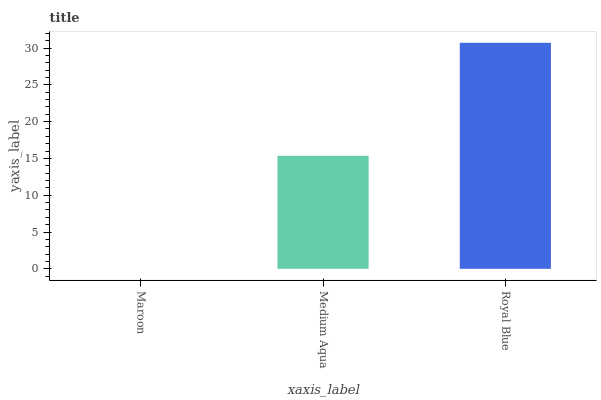Is Maroon the minimum?
Answer yes or no. Yes. Is Royal Blue the maximum?
Answer yes or no. Yes. Is Medium Aqua the minimum?
Answer yes or no. No. Is Medium Aqua the maximum?
Answer yes or no. No. Is Medium Aqua greater than Maroon?
Answer yes or no. Yes. Is Maroon less than Medium Aqua?
Answer yes or no. Yes. Is Maroon greater than Medium Aqua?
Answer yes or no. No. Is Medium Aqua less than Maroon?
Answer yes or no. No. Is Medium Aqua the high median?
Answer yes or no. Yes. Is Medium Aqua the low median?
Answer yes or no. Yes. Is Maroon the high median?
Answer yes or no. No. Is Maroon the low median?
Answer yes or no. No. 